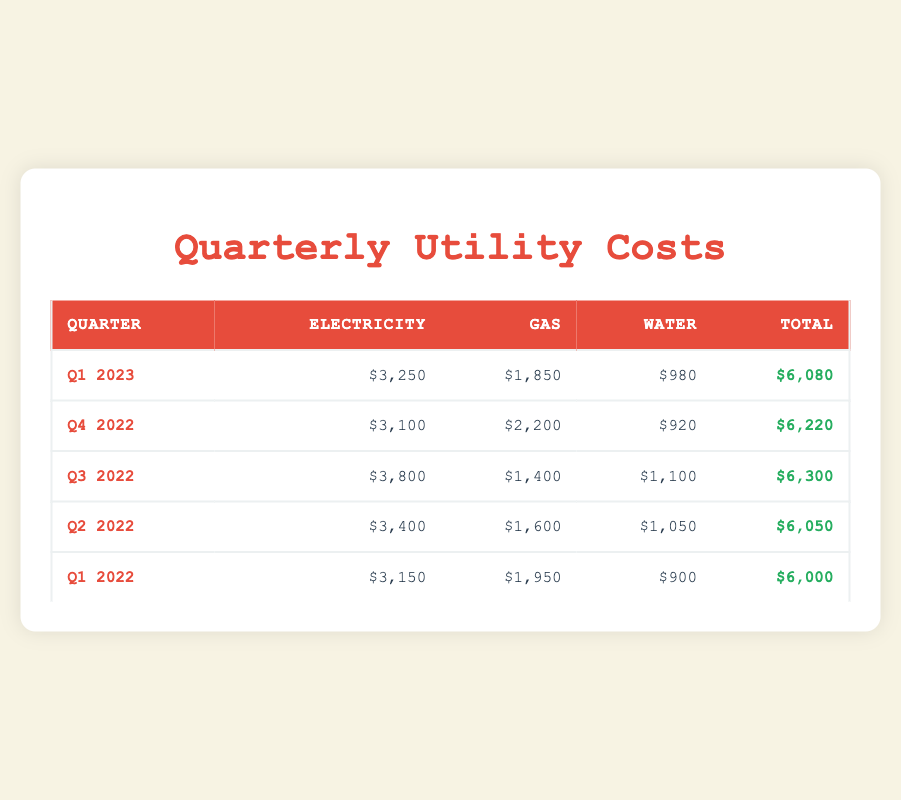What were the total utility costs for Q1 2023? Referring directly to the table under the 'Total' column for Q1 2023, the value is listed as $6,080.
Answer: $6,080 Which quarter had the highest electricity cost? Looking at the 'Electricity' column, Q3 2022 has the highest value at $3,800.
Answer: Q3 2022 What is the difference in total utility costs between Q4 2022 and Q2 2022? The total costs for Q4 2022 are $6,220 and for Q2 2022 are $6,050. The difference is $6,220 - $6,050 = $170.
Answer: $170 Did the gas costs increase from Q1 2022 to Q1 2023? The gas cost in Q1 2022 was $1,950, and in Q1 2023 it is $1,850. Since $1,850 is less than $1,950, the costs did not increase.
Answer: No What is the average water cost across all quarters? The water costs are $980, $920, $1,100, $1,050, and $900. Adding these gives $4,950. There are 5 quarters, so the average is $4,950 / 5 = $990.
Answer: $990 Which quarter had the lowest total utility costs? By checking the 'Total' column, Q1 2022 shows the lowest total at $6,000 compared to other quarters.
Answer: Q1 2022 If you take the total costs of Q1 2023 and subtract the total costs of Q4 2022, what is the result? Q1 2023 total is $6,080 and Q4 2022 total is $6,220. The subtraction is $6,080 - $6,220 = -$140.
Answer: -$140 Is the total utility cost for Q3 2022 more than Q4 2022? The total for Q3 2022 is $6,300, and for Q4 2022 it is $6,220. Since $6,300 is greater than $6,220, the statement is true.
Answer: Yes What is the total cost of electricity for all quarters combined? The total costs for electricity across all quarters are: $3,250 + $3,100 + $3,800 + $3,400 + $3,150 = $16,700.
Answer: $16,700 